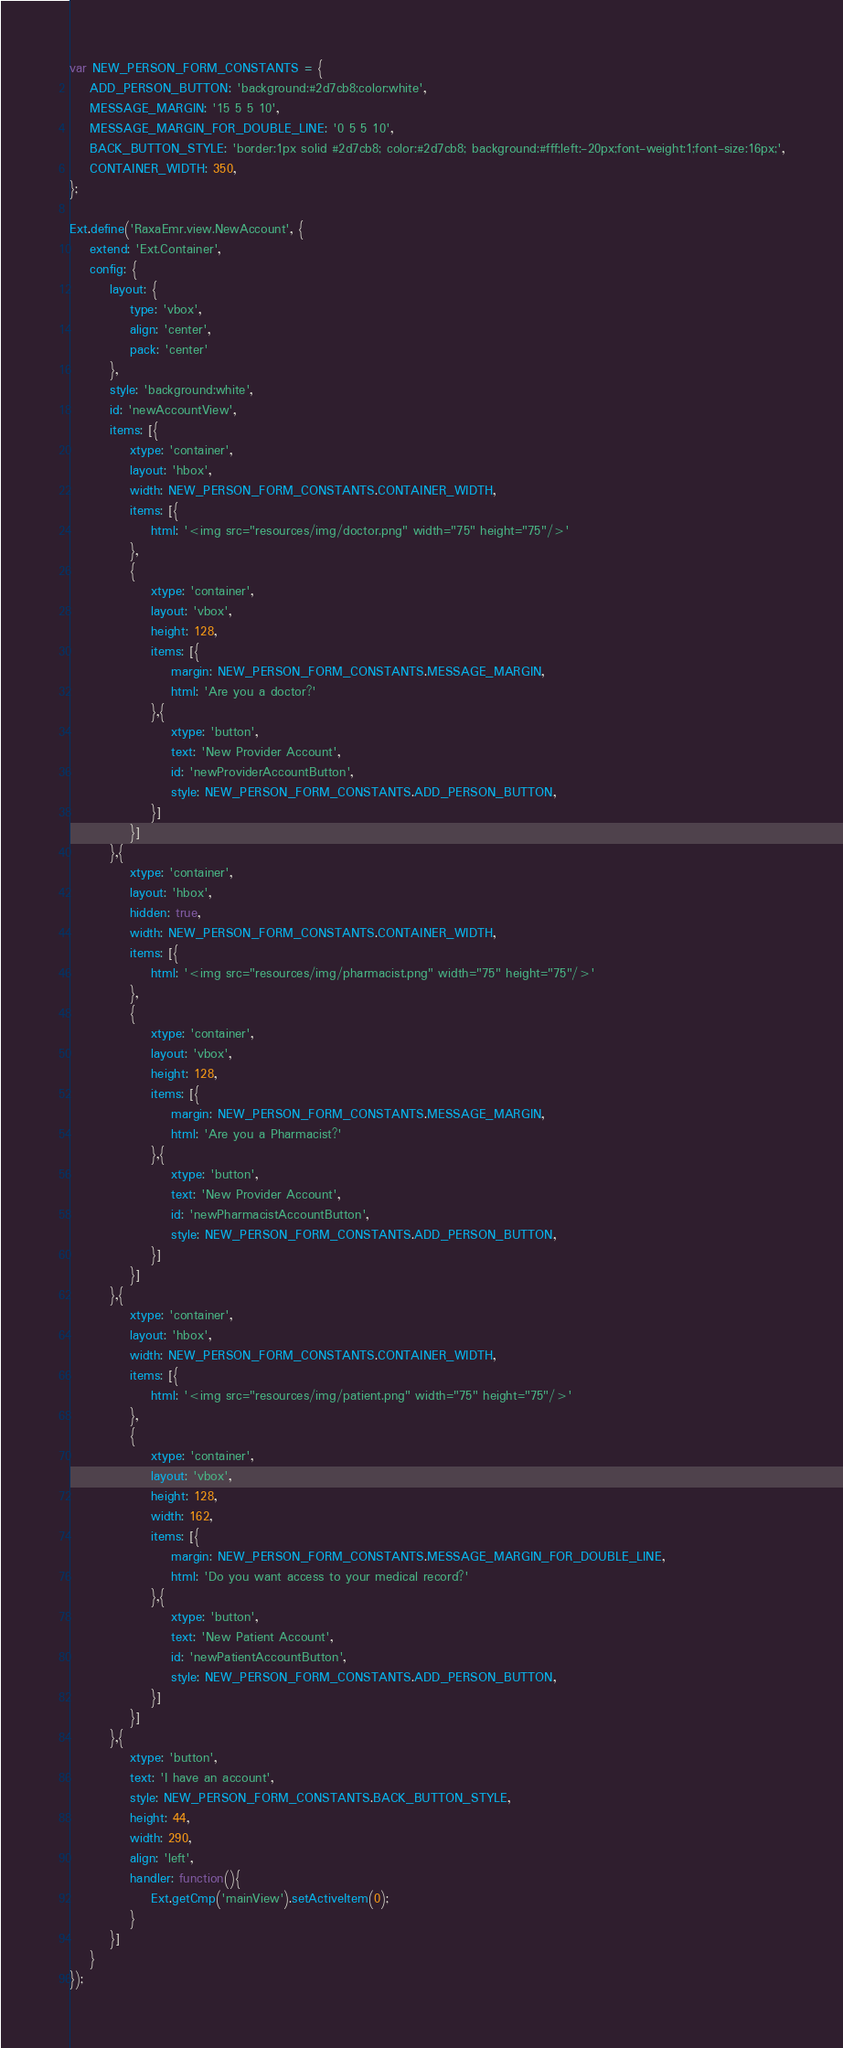Convert code to text. <code><loc_0><loc_0><loc_500><loc_500><_JavaScript_>var NEW_PERSON_FORM_CONSTANTS = {
    ADD_PERSON_BUTTON: 'background:#2d7cb8;color:white',
    MESSAGE_MARGIN: '15 5 5 10',
    MESSAGE_MARGIN_FOR_DOUBLE_LINE: '0 5 5 10',
    BACK_BUTTON_STYLE: 'border:1px solid #2d7cb8; color:#2d7cb8; background:#fff;left:-20px;font-weight:1;font-size:16px;',
    CONTAINER_WIDTH: 350,
};

Ext.define('RaxaEmr.view.NewAccount', {
    extend: 'Ext.Container',
    config: {
        layout: {
            type: 'vbox',
            align: 'center',
            pack: 'center'
        },
        style: 'background:white',
        id: 'newAccountView',
        items: [{
            xtype: 'container',
            layout: 'hbox',
            width: NEW_PERSON_FORM_CONSTANTS.CONTAINER_WIDTH,
            items: [{
                html: '<img src="resources/img/doctor.png" width="75" height="75"/>'
            },
            {
                xtype: 'container',
                layout: 'vbox',
                height: 128,
                items: [{
                    margin: NEW_PERSON_FORM_CONSTANTS.MESSAGE_MARGIN,
                    html: 'Are you a doctor?'
                },{
                    xtype: 'button',
                    text: 'New Provider Account',
                    id: 'newProviderAccountButton',
                    style: NEW_PERSON_FORM_CONSTANTS.ADD_PERSON_BUTTON,
                }]
            }]
        },{
            xtype: 'container',
            layout: 'hbox',
            hidden: true,
            width: NEW_PERSON_FORM_CONSTANTS.CONTAINER_WIDTH,
            items: [{
                html: '<img src="resources/img/pharmacist.png" width="75" height="75"/>'
            },
            {
                xtype: 'container',
                layout: 'vbox',
                height: 128,
                items: [{
                    margin: NEW_PERSON_FORM_CONSTANTS.MESSAGE_MARGIN,
                    html: 'Are you a Pharmacist?'
                },{
                    xtype: 'button',
                    text: 'New Provider Account',
                    id: 'newPharmacistAccountButton',
                    style: NEW_PERSON_FORM_CONSTANTS.ADD_PERSON_BUTTON,
                }]
            }]
        },{
            xtype: 'container',
            layout: 'hbox',
            width: NEW_PERSON_FORM_CONSTANTS.CONTAINER_WIDTH,
            items: [{
                html: '<img src="resources/img/patient.png" width="75" height="75"/>'
            },
            {
                xtype: 'container',
                layout: 'vbox',
                height: 128,
                width: 162,
                items: [{
                    margin: NEW_PERSON_FORM_CONSTANTS.MESSAGE_MARGIN_FOR_DOUBLE_LINE,
                    html: 'Do you want access to your medical record?'
                },{
                    xtype: 'button',
                    text: 'New Patient Account',
                    id: 'newPatientAccountButton',
                    style: NEW_PERSON_FORM_CONSTANTS.ADD_PERSON_BUTTON,
                }]
            }]
        },{
            xtype: 'button',
            text: 'I have an account',
            style: NEW_PERSON_FORM_CONSTANTS.BACK_BUTTON_STYLE,
            height: 44,
            width: 290,
            align: 'left',
            handler: function(){
                Ext.getCmp('mainView').setActiveItem(0);
            }
        }]
    }
});
</code> 